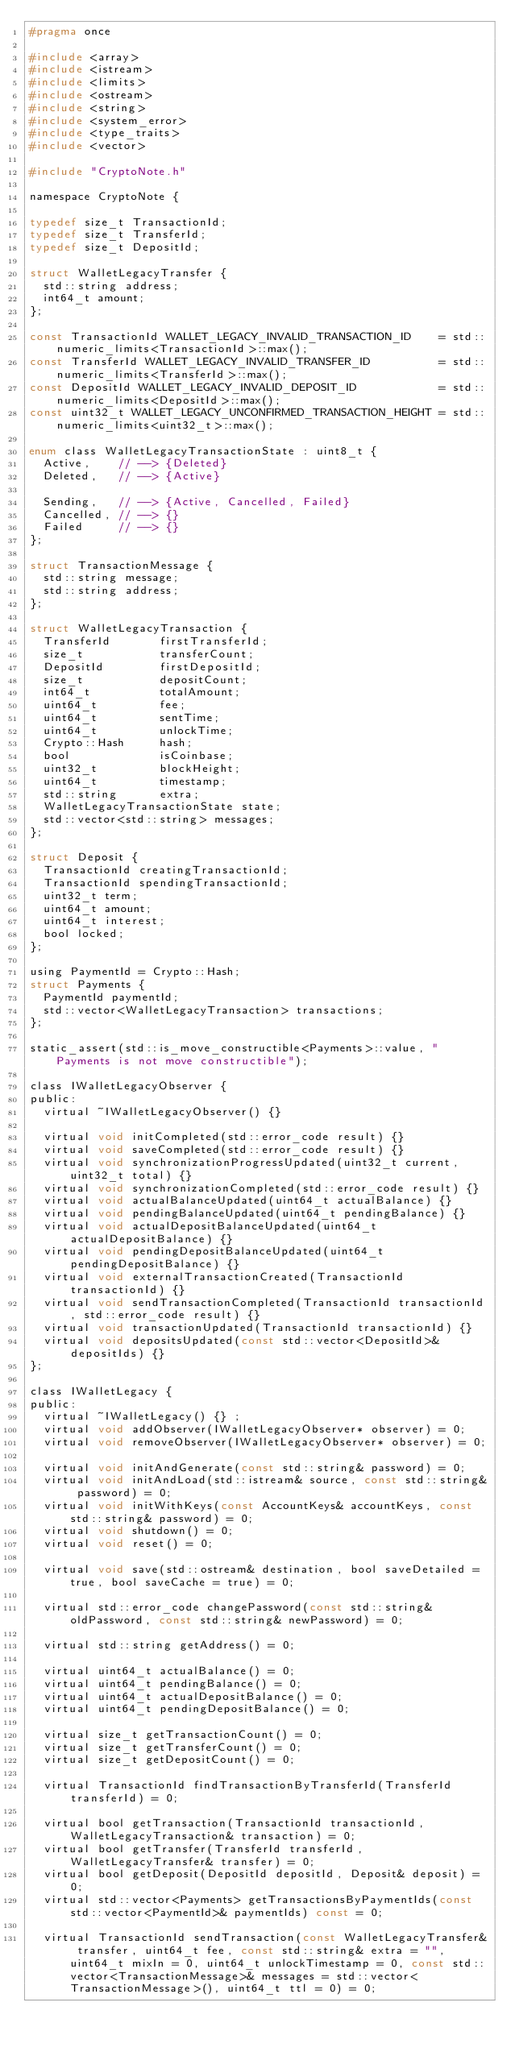<code> <loc_0><loc_0><loc_500><loc_500><_C_>#pragma once

#include <array>
#include <istream>
#include <limits>
#include <ostream>
#include <string>
#include <system_error>
#include <type_traits>
#include <vector>

#include "CryptoNote.h"

namespace CryptoNote {

typedef size_t TransactionId;
typedef size_t TransferId;
typedef size_t DepositId;

struct WalletLegacyTransfer {
  std::string address;
  int64_t amount;
};

const TransactionId WALLET_LEGACY_INVALID_TRANSACTION_ID    = std::numeric_limits<TransactionId>::max();
const TransferId WALLET_LEGACY_INVALID_TRANSFER_ID          = std::numeric_limits<TransferId>::max();
const DepositId WALLET_LEGACY_INVALID_DEPOSIT_ID            = std::numeric_limits<DepositId>::max();
const uint32_t WALLET_LEGACY_UNCONFIRMED_TRANSACTION_HEIGHT = std::numeric_limits<uint32_t>::max();

enum class WalletLegacyTransactionState : uint8_t {
  Active,    // --> {Deleted}
  Deleted,   // --> {Active}

  Sending,   // --> {Active, Cancelled, Failed}
  Cancelled, // --> {}
  Failed     // --> {}
};

struct TransactionMessage {
  std::string message;
  std::string address;
};

struct WalletLegacyTransaction {
  TransferId       firstTransferId;
  size_t           transferCount;
  DepositId        firstDepositId;
  size_t           depositCount;
  int64_t          totalAmount;
  uint64_t         fee;
  uint64_t         sentTime;
  uint64_t         unlockTime;
  Crypto::Hash     hash;
  bool             isCoinbase;
  uint32_t         blockHeight;
  uint64_t         timestamp;
  std::string      extra;
  WalletLegacyTransactionState state;
  std::vector<std::string> messages;
};

struct Deposit {
  TransactionId creatingTransactionId;
  TransactionId spendingTransactionId;
  uint32_t term;
  uint64_t amount;
  uint64_t interest;
  bool locked;
};

using PaymentId = Crypto::Hash;
struct Payments {
  PaymentId paymentId;
  std::vector<WalletLegacyTransaction> transactions;
};

static_assert(std::is_move_constructible<Payments>::value, "Payments is not move constructible");

class IWalletLegacyObserver {
public:
  virtual ~IWalletLegacyObserver() {}

  virtual void initCompleted(std::error_code result) {}
  virtual void saveCompleted(std::error_code result) {}
  virtual void synchronizationProgressUpdated(uint32_t current, uint32_t total) {}
  virtual void synchronizationCompleted(std::error_code result) {}
  virtual void actualBalanceUpdated(uint64_t actualBalance) {}
  virtual void pendingBalanceUpdated(uint64_t pendingBalance) {}
  virtual void actualDepositBalanceUpdated(uint64_t actualDepositBalance) {}
  virtual void pendingDepositBalanceUpdated(uint64_t pendingDepositBalance) {}
  virtual void externalTransactionCreated(TransactionId transactionId) {}
  virtual void sendTransactionCompleted(TransactionId transactionId, std::error_code result) {}
  virtual void transactionUpdated(TransactionId transactionId) {}
  virtual void depositsUpdated(const std::vector<DepositId>& depositIds) {}
};

class IWalletLegacy {
public:
  virtual ~IWalletLegacy() {} ;
  virtual void addObserver(IWalletLegacyObserver* observer) = 0;
  virtual void removeObserver(IWalletLegacyObserver* observer) = 0;

  virtual void initAndGenerate(const std::string& password) = 0;
  virtual void initAndLoad(std::istream& source, const std::string& password) = 0;
  virtual void initWithKeys(const AccountKeys& accountKeys, const std::string& password) = 0;
  virtual void shutdown() = 0;
  virtual void reset() = 0;

  virtual void save(std::ostream& destination, bool saveDetailed = true, bool saveCache = true) = 0;

  virtual std::error_code changePassword(const std::string& oldPassword, const std::string& newPassword) = 0;

  virtual std::string getAddress() = 0;

  virtual uint64_t actualBalance() = 0;
  virtual uint64_t pendingBalance() = 0;
  virtual uint64_t actualDepositBalance() = 0;
  virtual uint64_t pendingDepositBalance() = 0;

  virtual size_t getTransactionCount() = 0;
  virtual size_t getTransferCount() = 0;
  virtual size_t getDepositCount() = 0;

  virtual TransactionId findTransactionByTransferId(TransferId transferId) = 0;
  
  virtual bool getTransaction(TransactionId transactionId, WalletLegacyTransaction& transaction) = 0;
  virtual bool getTransfer(TransferId transferId, WalletLegacyTransfer& transfer) = 0;
  virtual bool getDeposit(DepositId depositId, Deposit& deposit) = 0;
  virtual std::vector<Payments> getTransactionsByPaymentIds(const std::vector<PaymentId>& paymentIds) const = 0;

  virtual TransactionId sendTransaction(const WalletLegacyTransfer& transfer, uint64_t fee, const std::string& extra = "", uint64_t mixIn = 0, uint64_t unlockTimestamp = 0, const std::vector<TransactionMessage>& messages = std::vector<TransactionMessage>(), uint64_t ttl = 0) = 0;</code> 